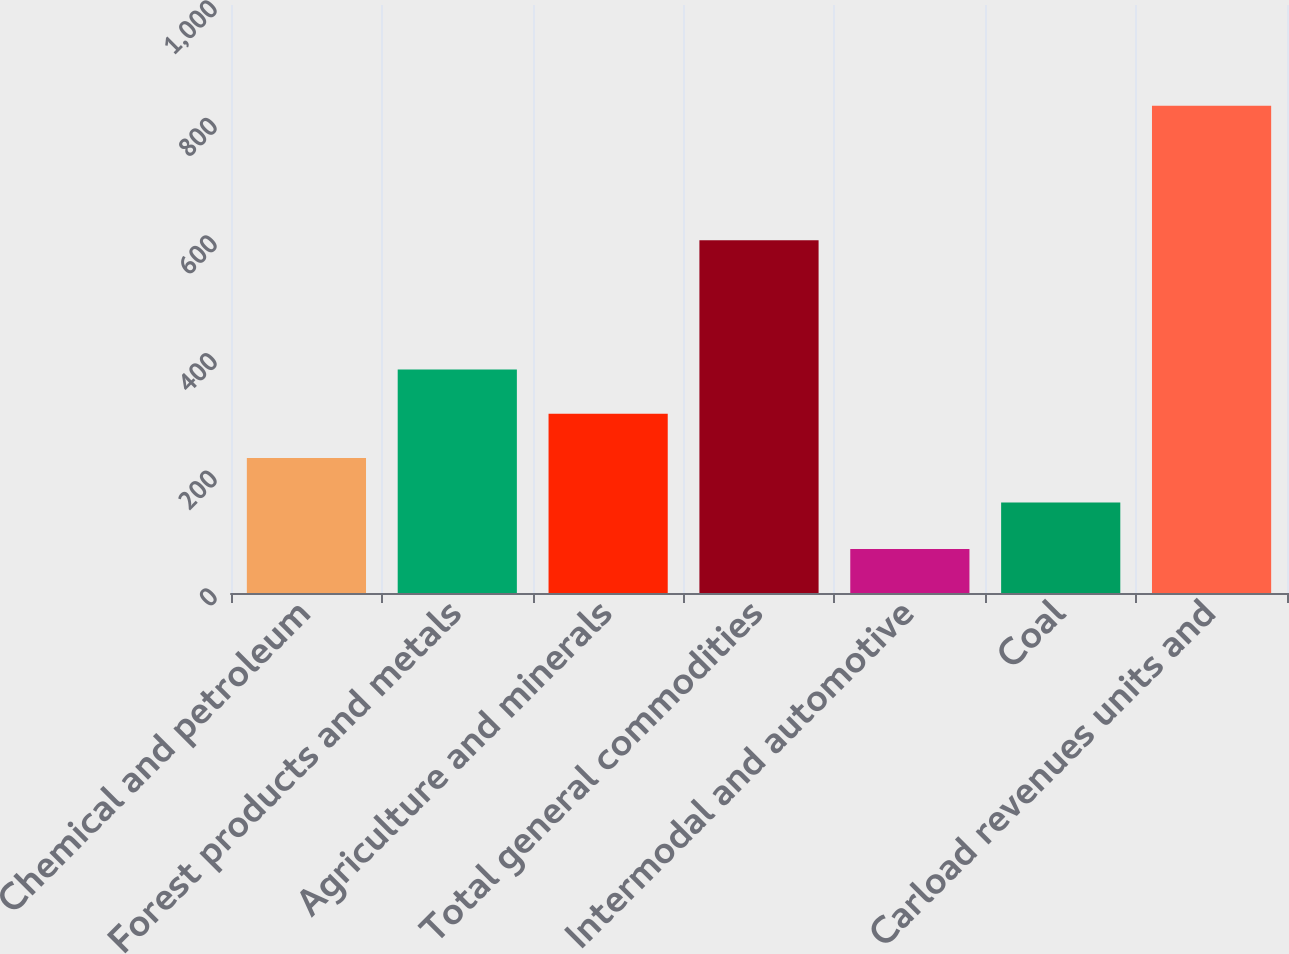<chart> <loc_0><loc_0><loc_500><loc_500><bar_chart><fcel>Chemical and petroleum<fcel>Forest products and metals<fcel>Agriculture and minerals<fcel>Total general commodities<fcel>Intermodal and automotive<fcel>Coal<fcel>Carload revenues units and<nl><fcel>229.49<fcel>380.27<fcel>304.88<fcel>599.8<fcel>74.8<fcel>154.1<fcel>828.7<nl></chart> 